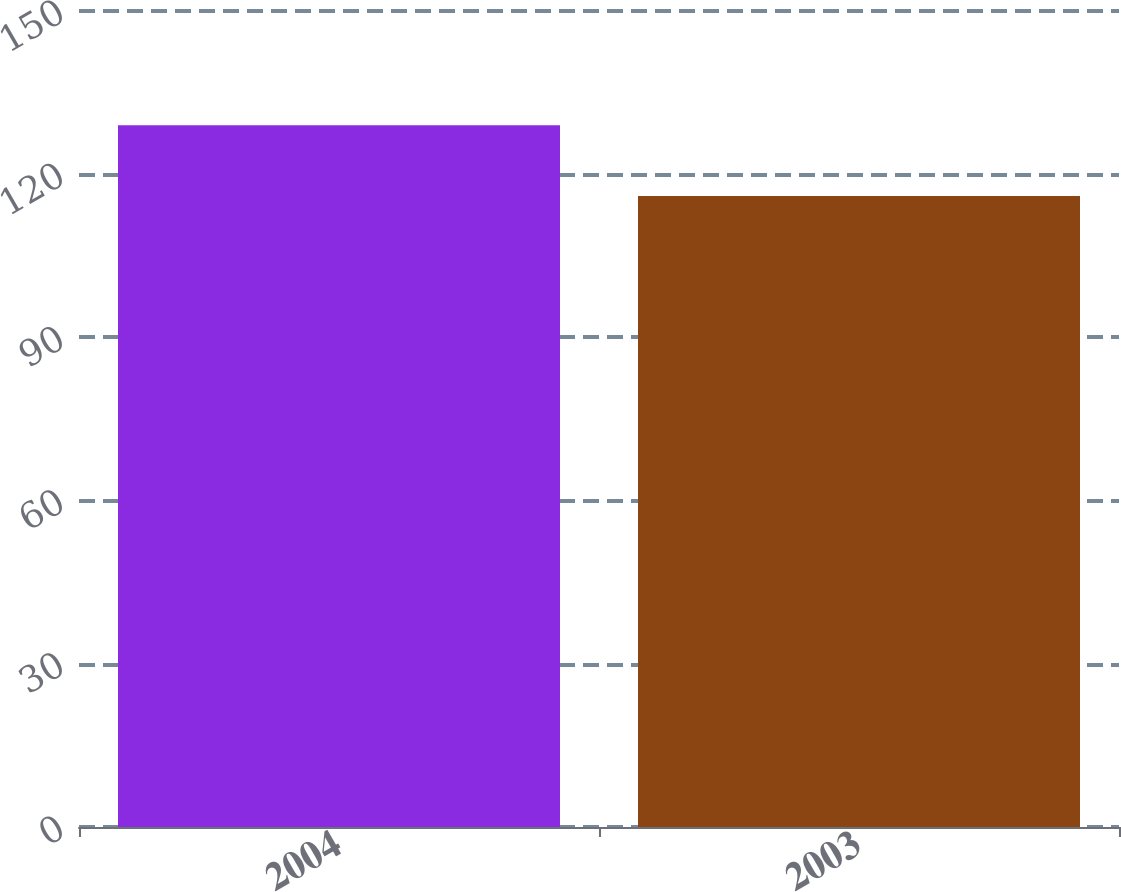Convert chart. <chart><loc_0><loc_0><loc_500><loc_500><bar_chart><fcel>2004<fcel>2003<nl><fcel>129<fcel>116<nl></chart> 